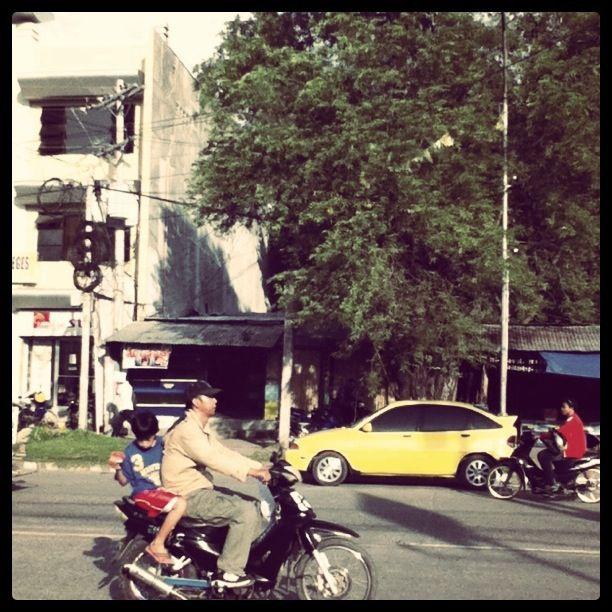Who is riding on the back of a bike?
Short answer required. Child. How many cars can be seen?
Be succinct. 1. Do more people drive motorcycles than cars?
Give a very brief answer. Yes. Is this a photo taken in the United States?
Be succinct. No. Is there a rider?
Be succinct. Yes. What color hat is the person driving the scooter in the foreground wearing?
Short answer required. Black. 